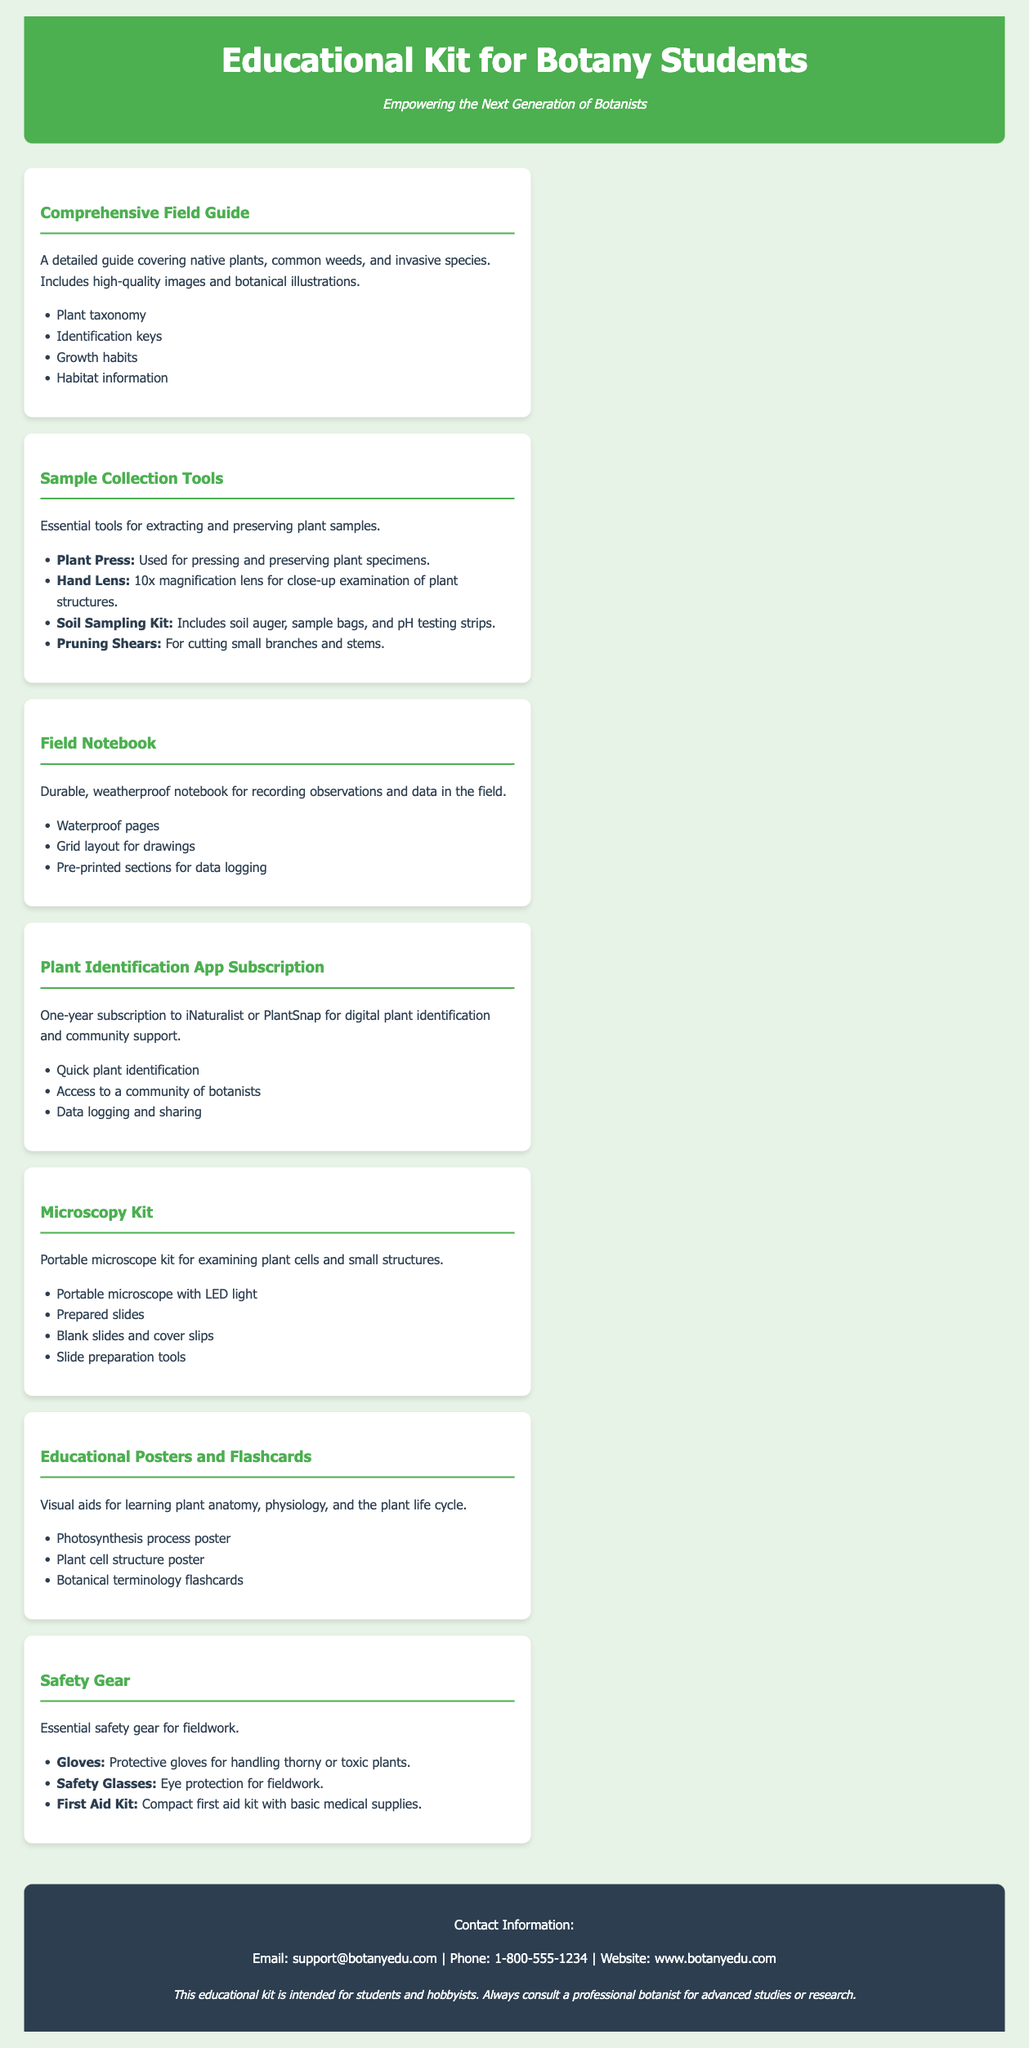What is the main title of the document? The main title is prominently displayed at the top of the document.
Answer: Educational Kit for Botany Students How many components are listed in the kit? The document lists various components, and counting them reveals the total number.
Answer: Seven What is included in the Sample Collection Tools section? The Sample Collection Tools section details essential tools, including a few specific items.
Answer: Plant Press, Hand Lens, Soil Sampling Kit, Pruning Shears What type of subscription is provided with the kit? The document specifies the type of subscription available as part of the kit components.
Answer: Plant Identification App Subscription What protective gear is mentioned under Safety Gear? The document outlines the items categorized as safety gear for fieldwork.
Answer: Gloves, Safety Glasses, First Aid Kit Which component has waterproof pages? The document details which specific item is designed for outdoor use and includes waterproof pages.
Answer: Field Notebook What is the purpose of the Educational Posters and Flashcards? The document explains the educational function of a specific component included in the kit.
Answer: Visual aids for learning plant anatomy, physiology, and the plant life cycle 